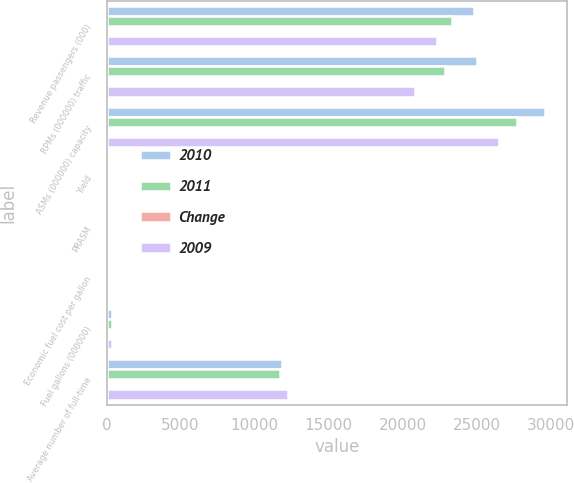Convert chart. <chart><loc_0><loc_0><loc_500><loc_500><stacked_bar_chart><ecel><fcel>Revenue passengers (000)<fcel>RPMs (000000) traffic<fcel>ASMs (000000) capacity<fcel>Yield<fcel>PRASM<fcel>Economic fuel cost per gallon<fcel>Fuel gallons (000000)<fcel>Average number of full-time<nl><fcel>2010<fcel>24790<fcel>25032<fcel>29627<fcel>15.78<fcel>13.33<fcel>3.18<fcel>398.3<fcel>11840<nl><fcel>2011<fcel>23334<fcel>22841<fcel>27736<fcel>15.27<fcel>12.58<fcel>2.37<fcel>377.3<fcel>11696<nl><fcel>Change<fcel>6.2<fcel>9.6<fcel>6.8<fcel>3.3<fcel>6<fcel>34.2<fcel>5.6<fcel>1.2<nl><fcel>2009<fcel>22320<fcel>20811<fcel>26501<fcel>14.93<fcel>11.73<fcel>2.05<fcel>365<fcel>12223<nl></chart> 